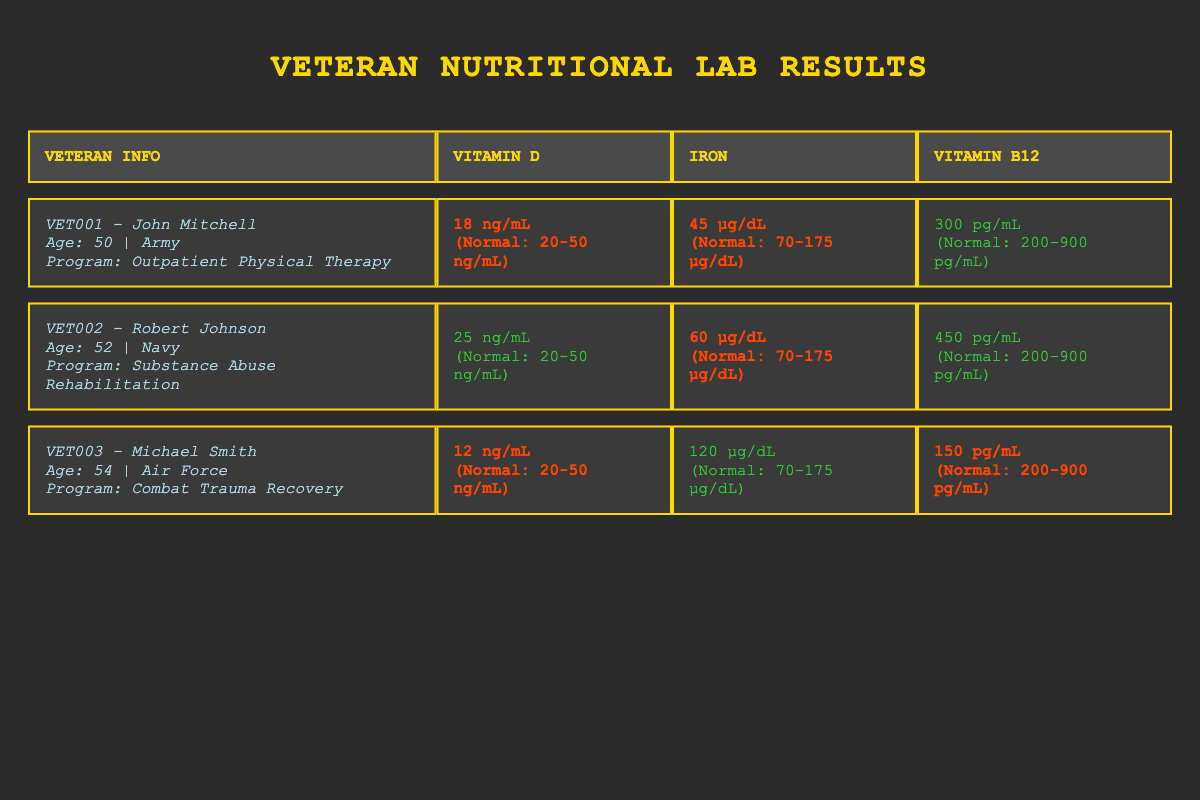What is the vitamin D level of John Mitchell? John Mitchell has a vitamin D level of 18 ng/mL, which can be found in the corresponding row under the "Vitamin D" column.
Answer: 18 ng/mL How many veterans have a deficiency in iron? By checking the "Iron" column, Robert Johnson and John Mitchell show deficiency with levels of 60 µg/dL and 45 µg/dL respectively. Michael Smith does not have a deficiency with a level of 120 µg/dL. Thus, two veterans are deficient in iron.
Answer: 2 What is the range of Vitamin B12 considered normal? The normal range for Vitamin B12 is specified in the table as 200-900 pg/mL in the header for that column.
Answer: 200-900 pg/mL Is Michael Smith deficient in Vitamin D? In the table, under the "Vitamin D" column for Michael Smith, the result is shown as 12 ng/mL, which is below the normal range of 20-50 ng/mL, confirming he is deficient.
Answer: Yes What is the average level of Vitamin D among these veterans? The Vitamin D levels are 18 ng/mL, 25 ng/mL, and 12 ng/mL. To find the average, sum them up (18 + 25 + 12 = 55) and divide by the number of veterans (3). Thus, the average is 55/3 = 18.33 ng/mL.
Answer: 18.33 ng/mL 